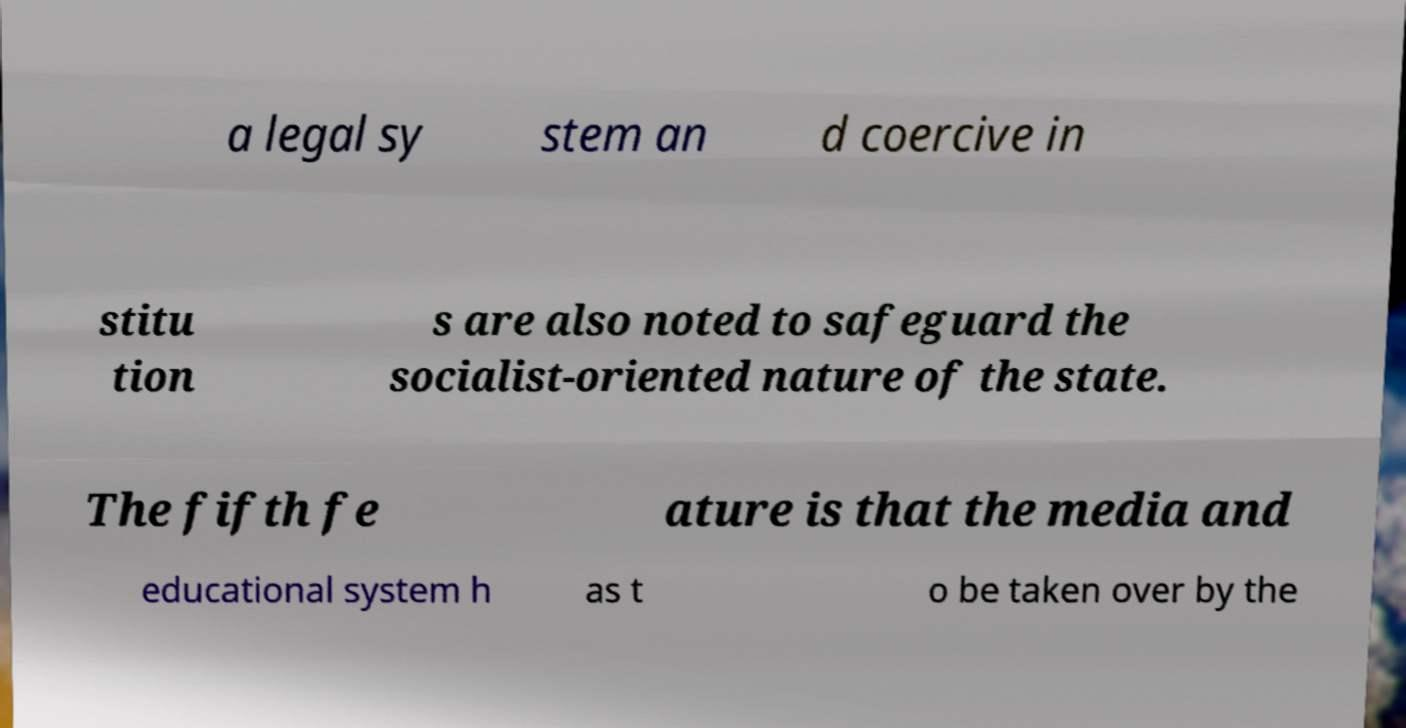Can you accurately transcribe the text from the provided image for me? a legal sy stem an d coercive in stitu tion s are also noted to safeguard the socialist-oriented nature of the state. The fifth fe ature is that the media and educational system h as t o be taken over by the 